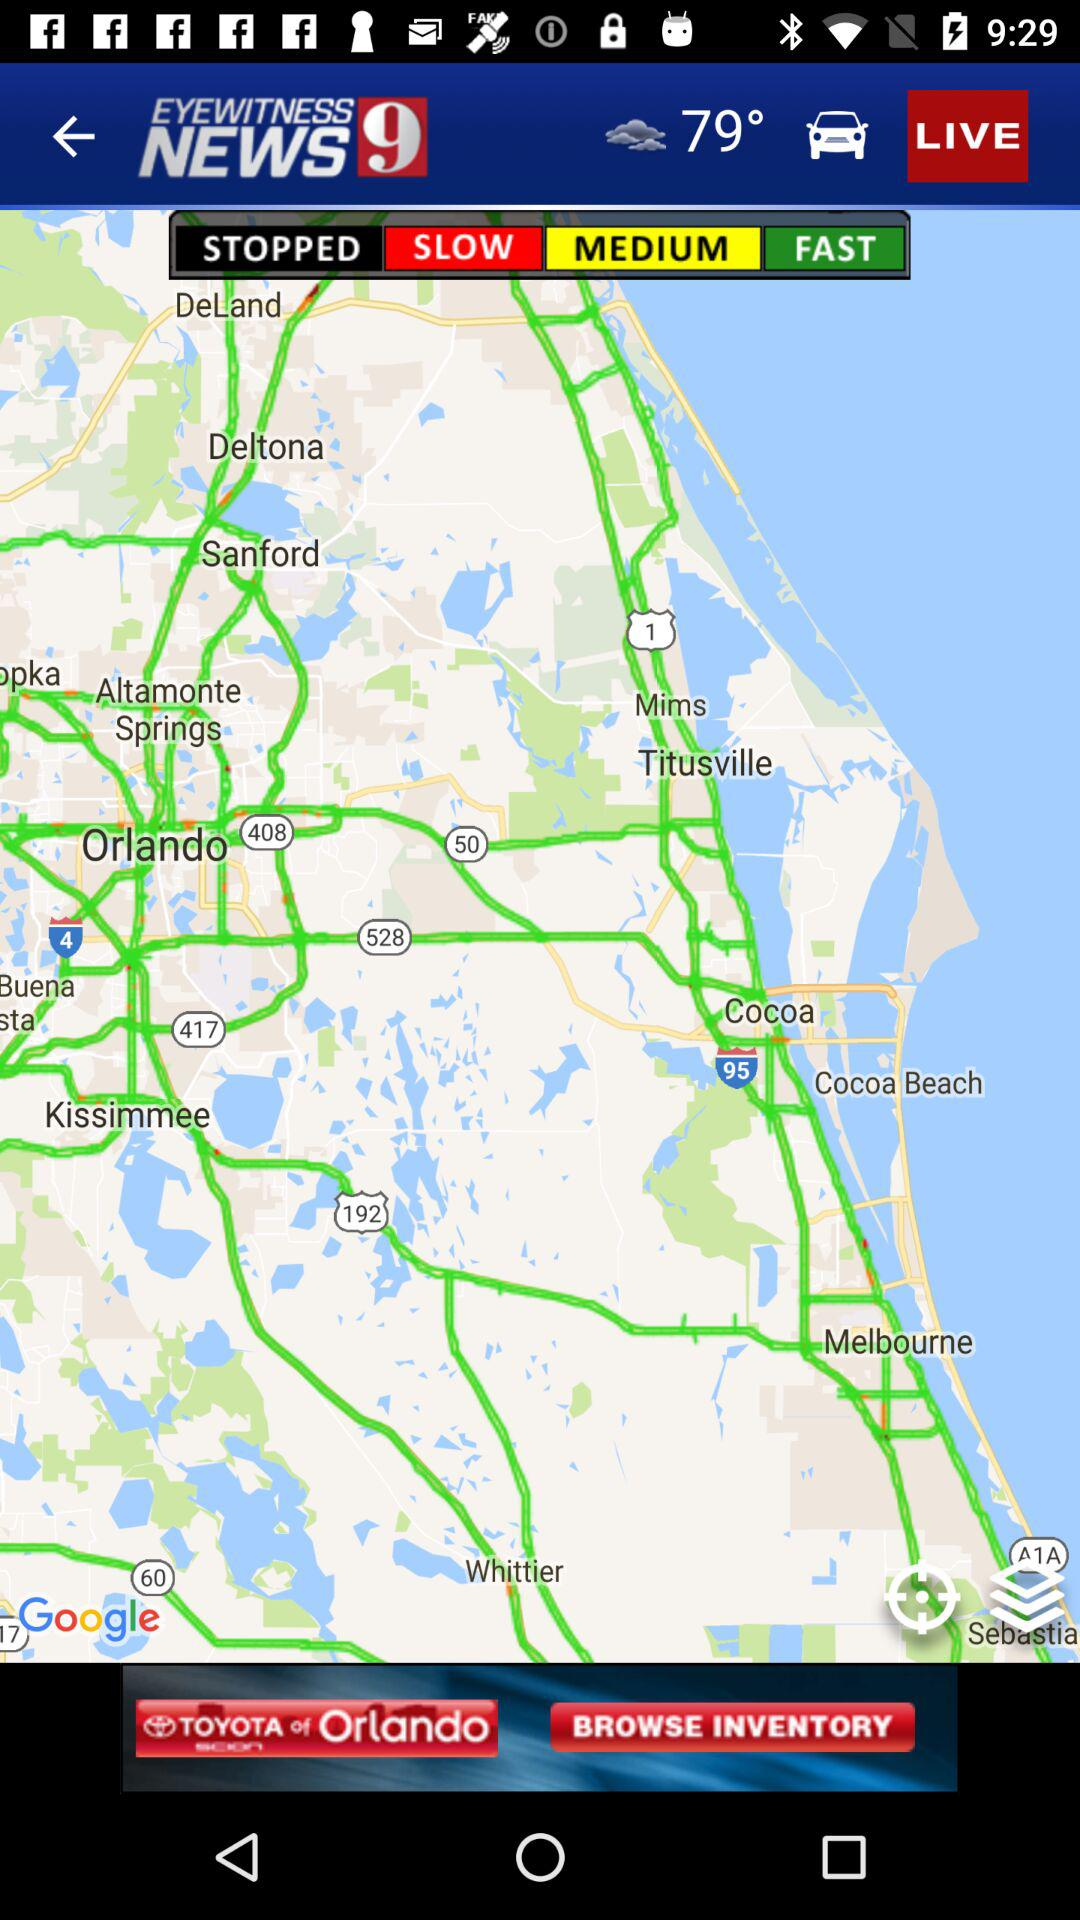What is the displayed temperature? The displayed temperature is 79°. 